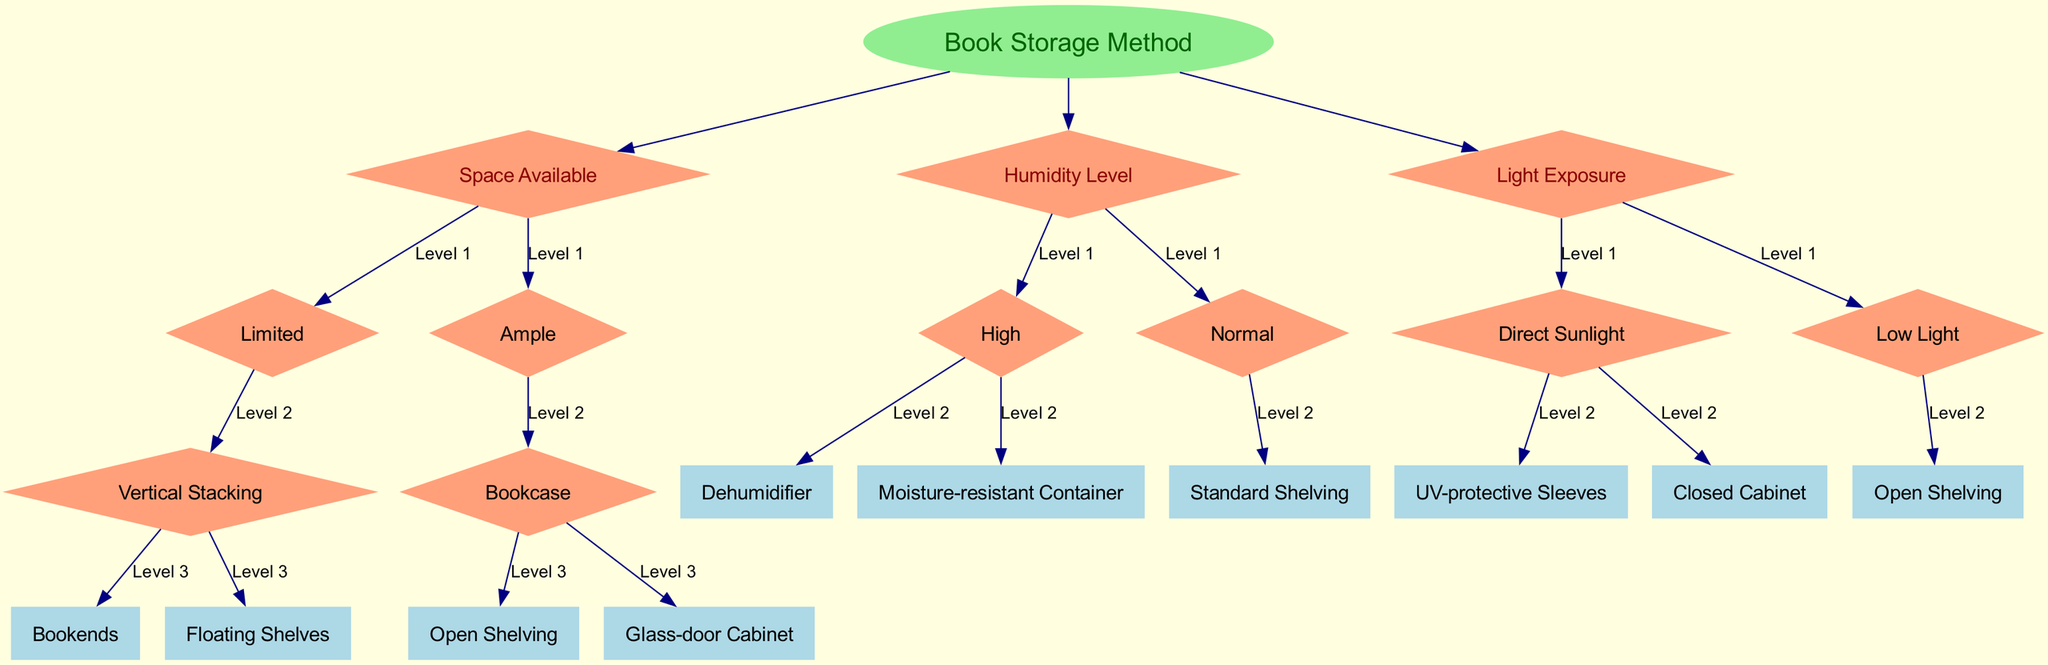What is the root of the decision tree? The root of the decision tree is labeled as "Book Storage Method." This is the starting point for evaluating different storage methods based on various factors.
Answer: Book Storage Method How many primary decision nodes are in the diagram? There are three primary decision nodes shown in the diagram: "Space Available," "Humidity Level," and "Light Exposure." Each of these nodes branches into further options based on the respective factors.
Answer: Three What storage method is recommended for limited space? For limited space, the recommended storage methods are "Vertical Stacking" with options for "Bookends" and "Floating Shelves." These options make efficient use of vertical space.
Answer: Vertical Stacking If the humidity level is high, what storage method should be used? If the humidity level is high, the recommended methods are "Dehumidifier" or "Moisture-resistant Container." These options help protect books from damage due to excess moisture.
Answer: Dehumidifier or Moisture-resistant Container Which storage method is suitable for direct sunlight exposure? For direct sunlight exposure, the suitable storage methods are "UV-protective Sleeves" and "Closed Cabinet." These protect books from potential damage caused by UV light.
Answer: UV-protective Sleeves or Closed Cabinet How does the decision tree categorize light exposure? The decision tree categorizes light exposure into two options: "Direct Sunlight" and "Low Light." Each option leads to different storage method suggestions based on how much light the books will receive.
Answer: Direct Sunlight or Low Light What is recommended for normal humidity levels? For normal humidity levels, the recommended storage method is "Standard Shelving." This option is adequate for book storage without special considerations for moisture control.
Answer: Standard Shelving What type of cabinet is suggested for ample space? For ample space, "Glass-door Cabinet" is one of the suggested storage methods, which allows for display while protecting books.
Answer: Glass-door Cabinet 